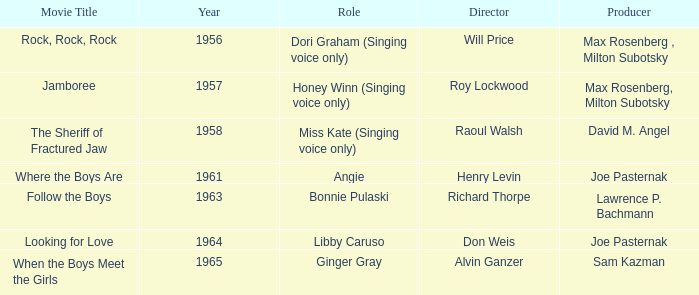What movie was made in 1957? Jamboree. 